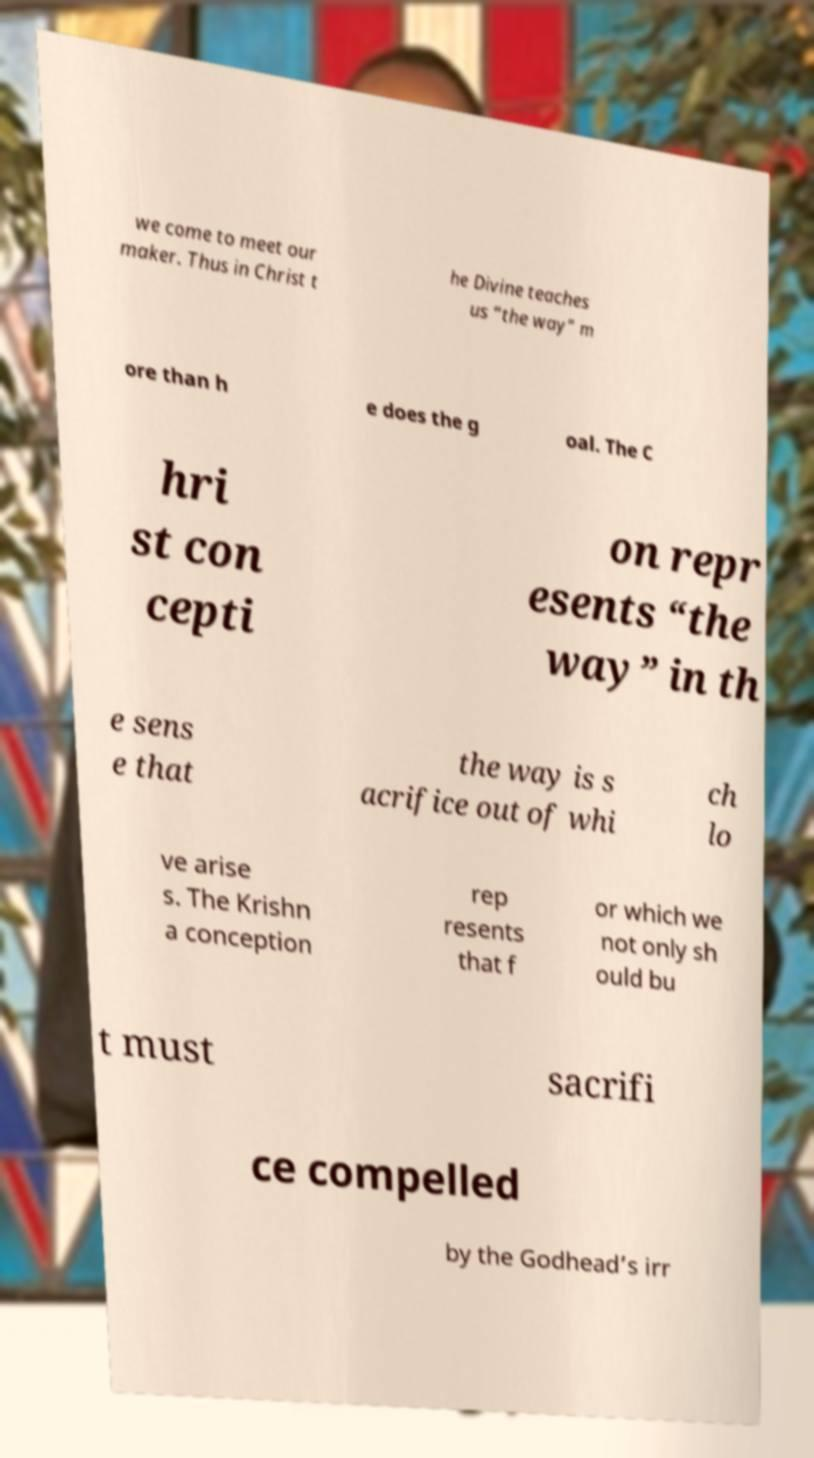Can you accurately transcribe the text from the provided image for me? we come to meet our maker. Thus in Christ t he Divine teaches us “the way” m ore than h e does the g oal. The C hri st con cepti on repr esents “the way” in th e sens e that the way is s acrifice out of whi ch lo ve arise s. The Krishn a conception rep resents that f or which we not only sh ould bu t must sacrifi ce compelled by the Godhead’s irr 